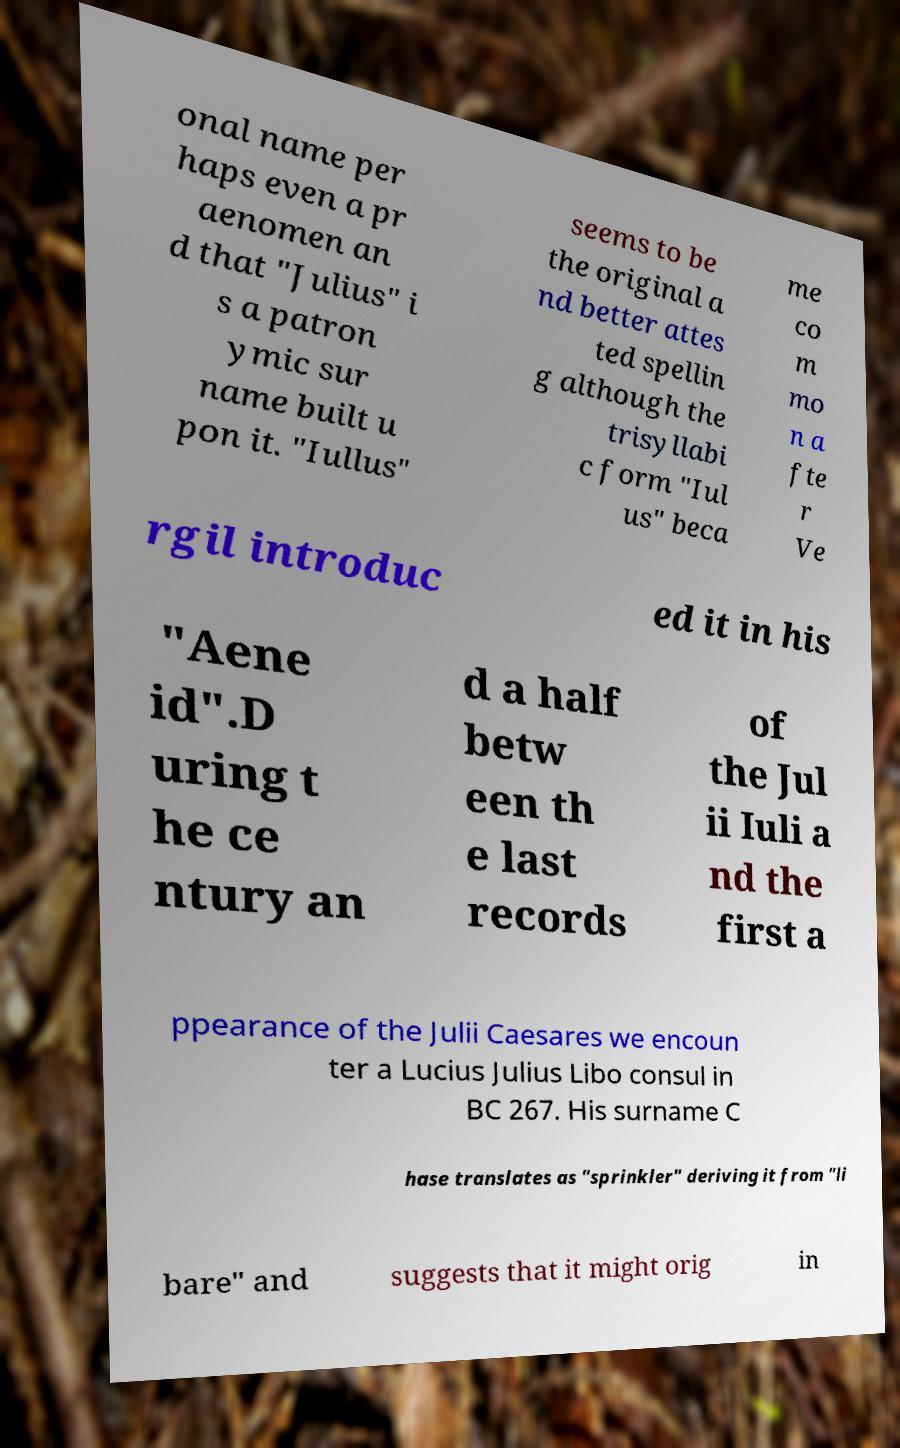Could you assist in decoding the text presented in this image and type it out clearly? onal name per haps even a pr aenomen an d that "Julius" i s a patron ymic sur name built u pon it. "Iullus" seems to be the original a nd better attes ted spellin g although the trisyllabi c form "Iul us" beca me co m mo n a fte r Ve rgil introduc ed it in his "Aene id".D uring t he ce ntury an d a half betw een th e last records of the Jul ii Iuli a nd the first a ppearance of the Julii Caesares we encoun ter a Lucius Julius Libo consul in BC 267. His surname C hase translates as "sprinkler" deriving it from "li bare" and suggests that it might orig in 